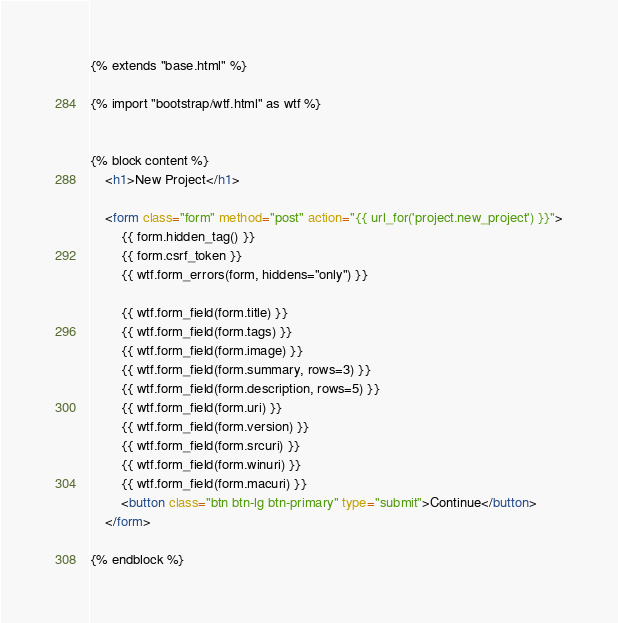<code> <loc_0><loc_0><loc_500><loc_500><_HTML_>{% extends "base.html" %}

{% import "bootstrap/wtf.html" as wtf %}


{% block content %}
	<h1>New Project</h1>

    <form class="form" method="post" action="{{ url_for('project.new_project') }}">
        {{ form.hidden_tag() }}
        {{ form.csrf_token }}
        {{ wtf.form_errors(form, hiddens="only") }}

        {{ wtf.form_field(form.title) }}
        {{ wtf.form_field(form.tags) }}
        {{ wtf.form_field(form.image) }}
        {{ wtf.form_field(form.summary, rows=3) }}
        {{ wtf.form_field(form.description, rows=5) }}
        {{ wtf.form_field(form.uri) }}
        {{ wtf.form_field(form.version) }}
        {{ wtf.form_field(form.srcuri) }}
        {{ wtf.form_field(form.winuri) }}
        {{ wtf.form_field(form.macuri) }}
        <button class="btn btn-lg btn-primary" type="submit">Continue</button>
    </form>

{% endblock %}</code> 